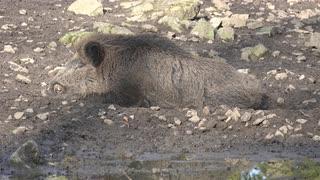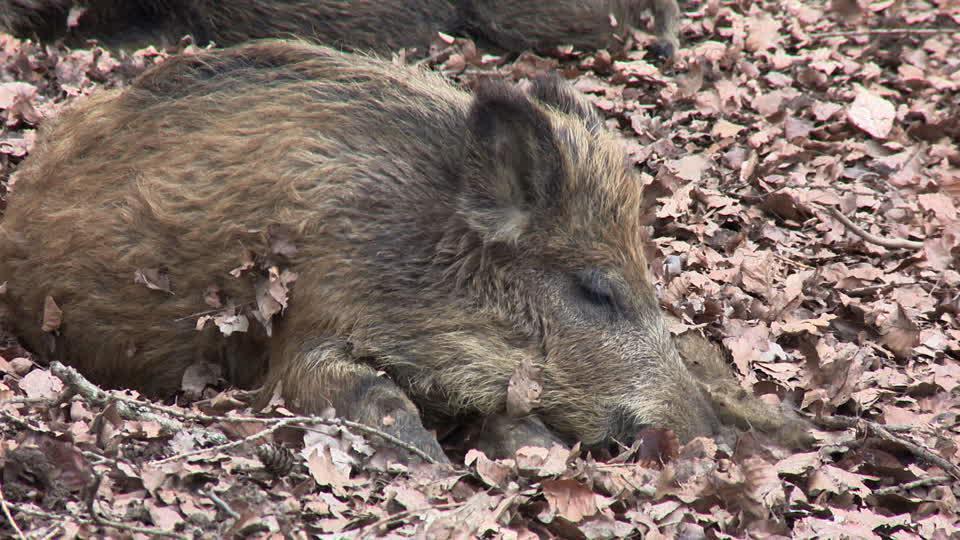The first image is the image on the left, the second image is the image on the right. For the images displayed, is the sentence "An image shows at least two baby piglets with distinctive striped fur lying in front of an older wild pig that is lying on its side." factually correct? Answer yes or no. No. The first image is the image on the left, the second image is the image on the right. Analyze the images presented: Is the assertion "The left image contains exactly one boar." valid? Answer yes or no. Yes. 